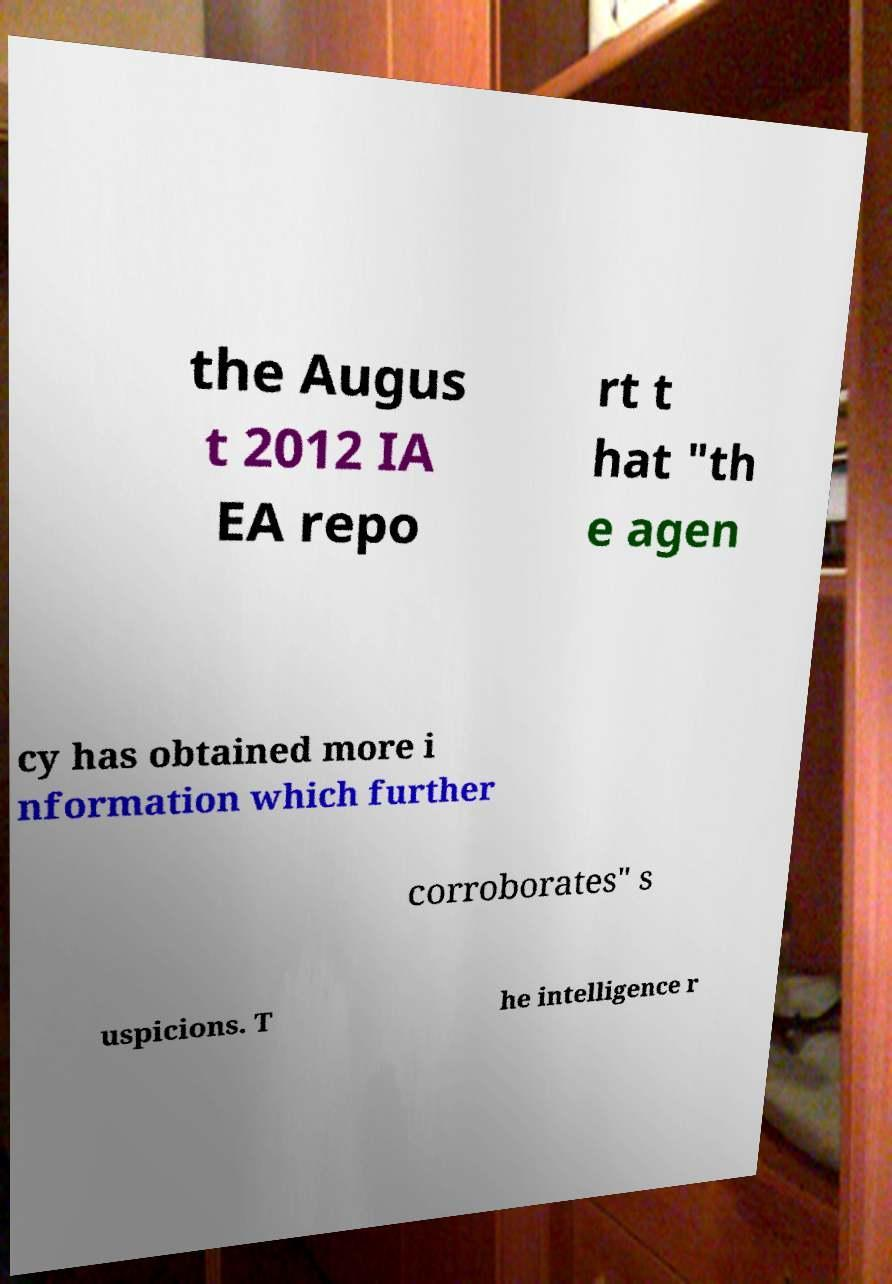Can you accurately transcribe the text from the provided image for me? the Augus t 2012 IA EA repo rt t hat "th e agen cy has obtained more i nformation which further corroborates" s uspicions. T he intelligence r 